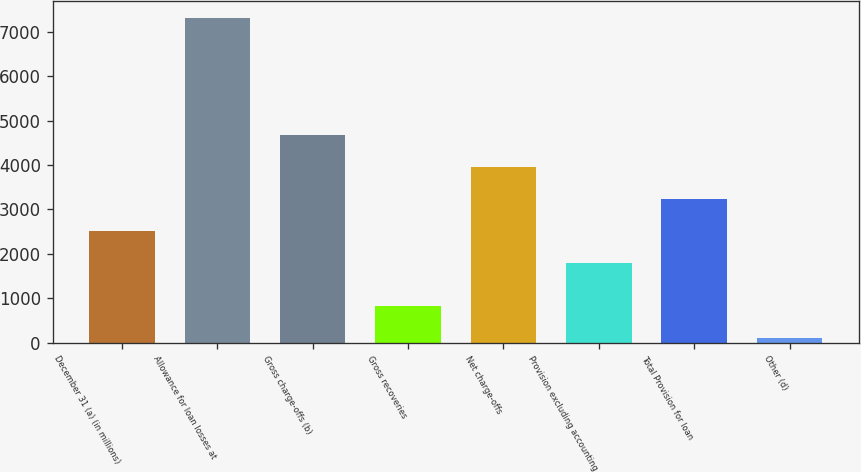Convert chart. <chart><loc_0><loc_0><loc_500><loc_500><bar_chart><fcel>December 31 (a) (in millions)<fcel>Allowance for loan losses at<fcel>Gross charge-offs (b)<fcel>Gross recoveries<fcel>Net charge-offs<fcel>Provision excluding accounting<fcel>Total Provision for loan<fcel>Other (d)<nl><fcel>2519<fcel>7320<fcel>4682<fcel>831<fcel>3961<fcel>1798<fcel>3240<fcel>110<nl></chart> 